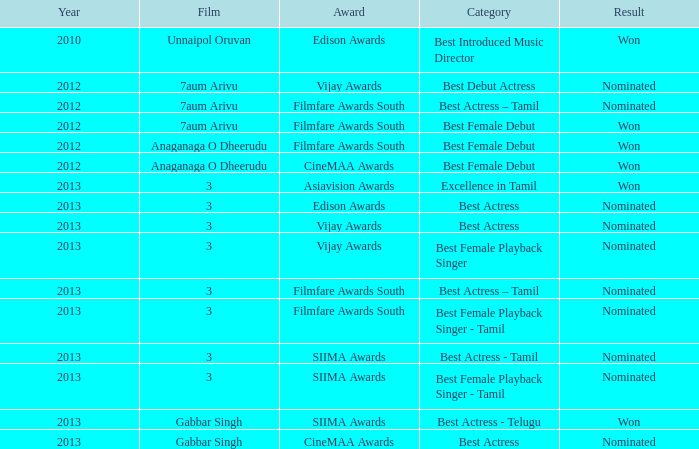What was the result associated with the cinemaa awards, and gabbar singh film? Nominated. 